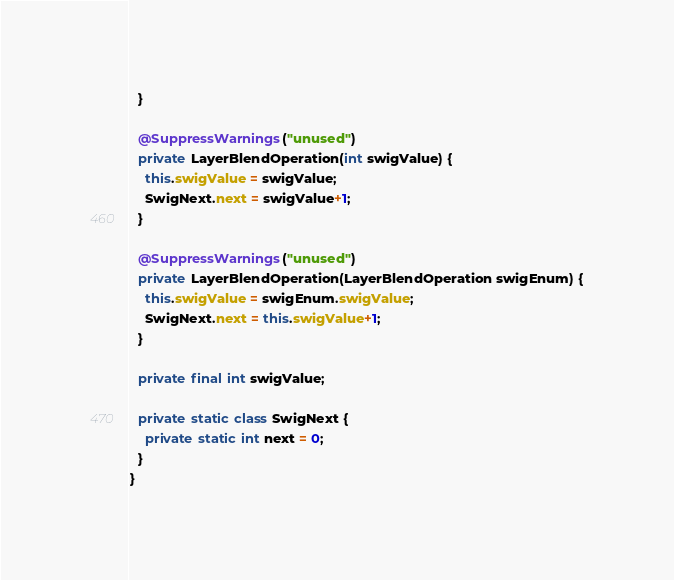<code> <loc_0><loc_0><loc_500><loc_500><_Java_>  }

  @SuppressWarnings("unused")
  private LayerBlendOperation(int swigValue) {
    this.swigValue = swigValue;
    SwigNext.next = swigValue+1;
  }

  @SuppressWarnings("unused")
  private LayerBlendOperation(LayerBlendOperation swigEnum) {
    this.swigValue = swigEnum.swigValue;
    SwigNext.next = this.swigValue+1;
  }

  private final int swigValue;

  private static class SwigNext {
    private static int next = 0;
  }
}

</code> 